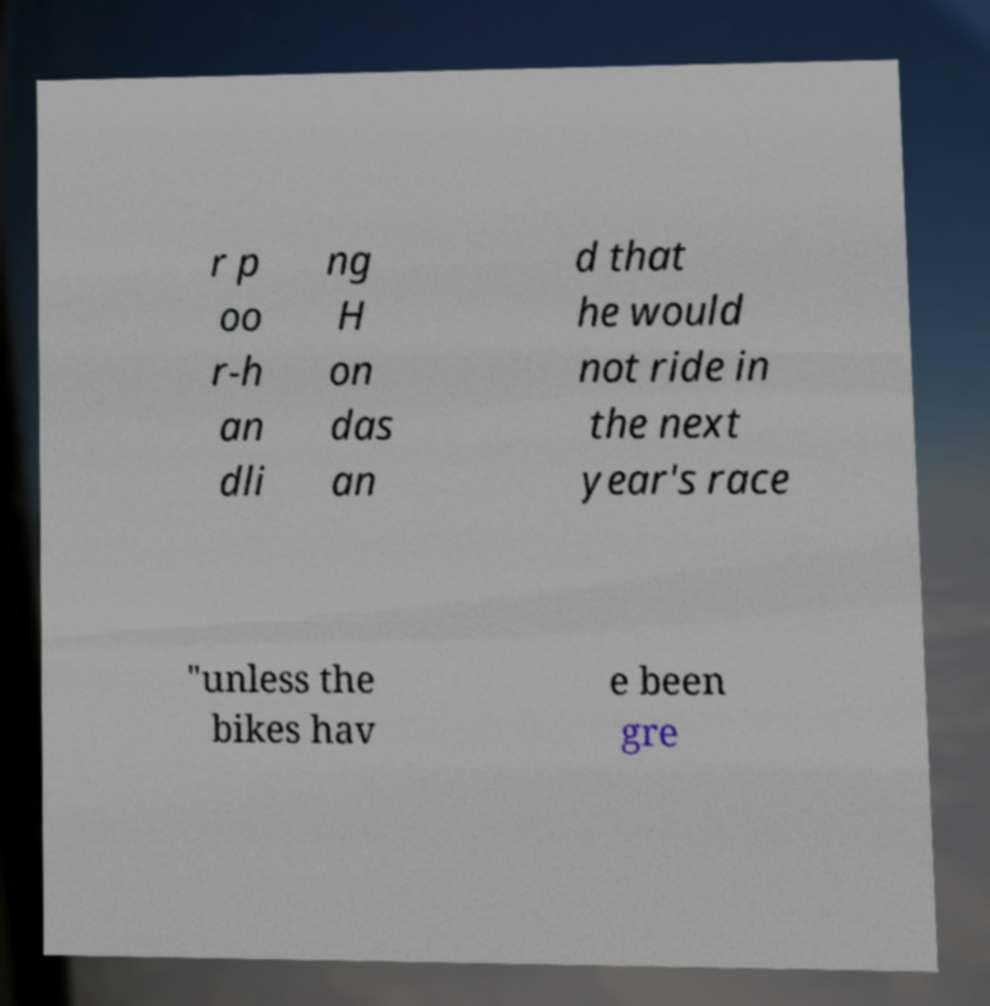Can you read and provide the text displayed in the image?This photo seems to have some interesting text. Can you extract and type it out for me? r p oo r-h an dli ng H on das an d that he would not ride in the next year's race "unless the bikes hav e been gre 